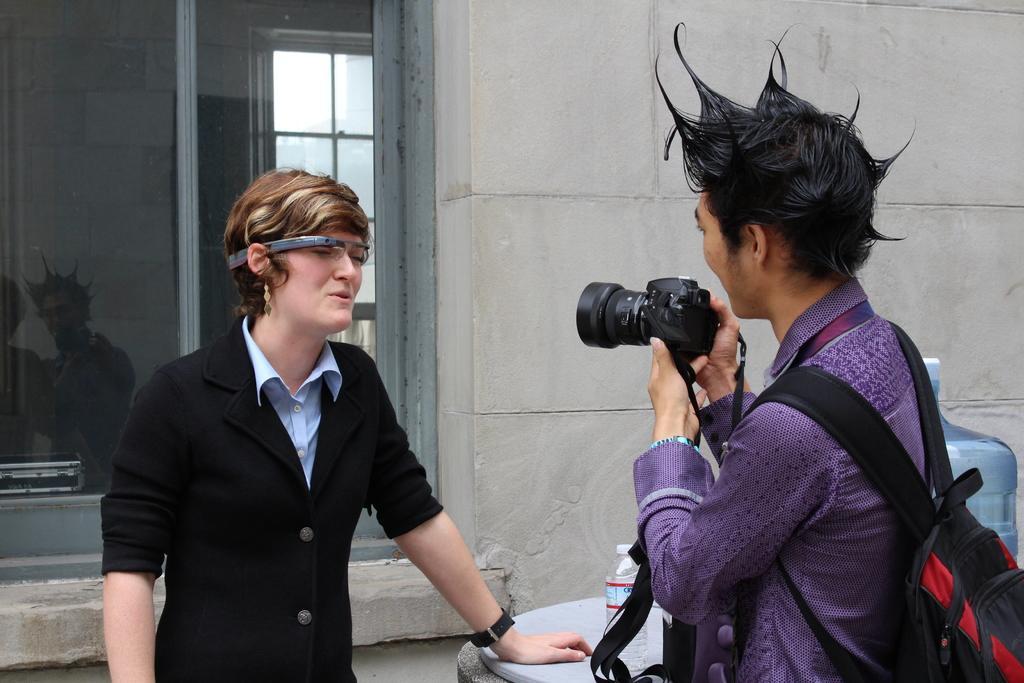Could you give a brief overview of what you see in this image? On the background we can see a wall and a window. Here we can see one man wearing a backpack and holding a camera and recording this man. Here we can see a water bottle. 